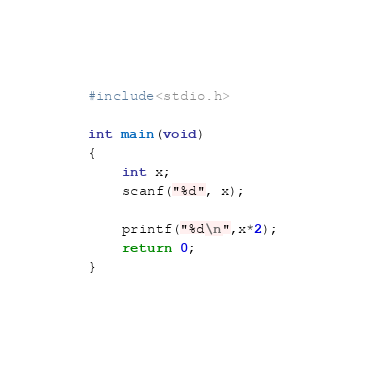Convert code to text. <code><loc_0><loc_0><loc_500><loc_500><_C_>#include<stdio.h>

int main(void)
{
    int x;
    scanf("%d", x);

    printf("%d\n",x*2);
    return 0;
}
 </code> 